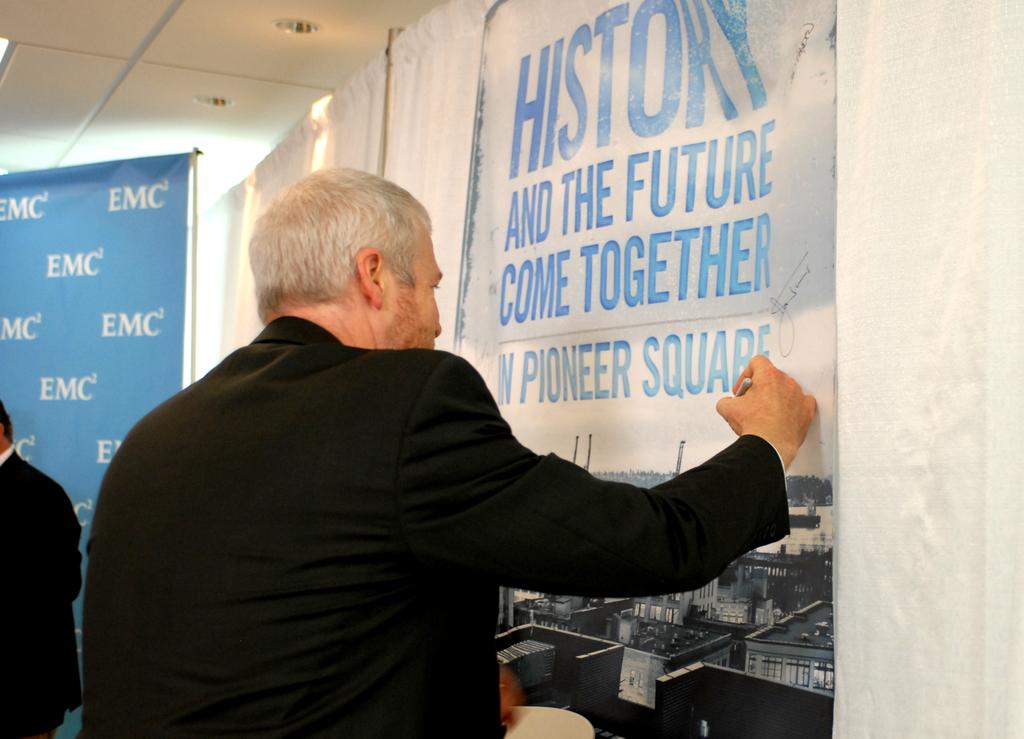What comes together?
Keep it short and to the point. History and the future. What square is on the banner?
Keep it short and to the point. Pioneer. 